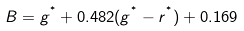Convert formula to latex. <formula><loc_0><loc_0><loc_500><loc_500>B = g ^ { ^ { * } } + 0 . 4 8 2 ( g ^ { ^ { * } } - r ^ { ^ { * } } ) + 0 . 1 6 9</formula> 